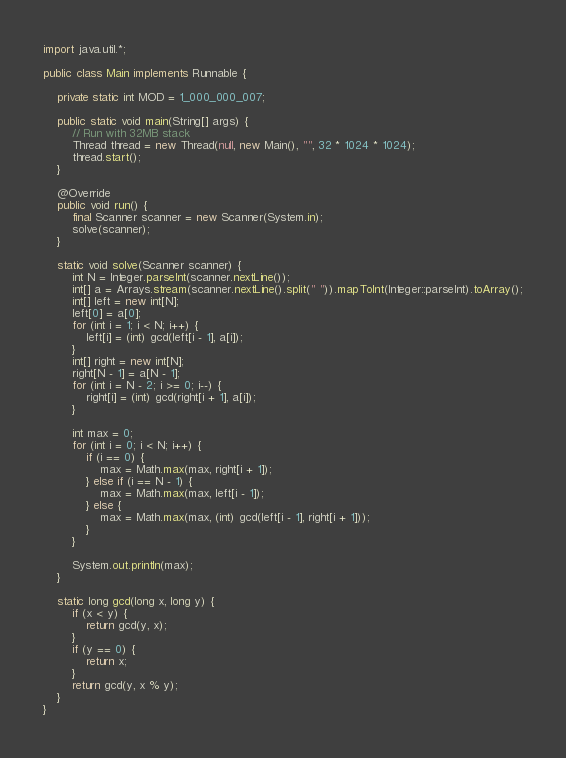<code> <loc_0><loc_0><loc_500><loc_500><_Java_>import java.util.*;

public class Main implements Runnable {

    private static int MOD = 1_000_000_007;

    public static void main(String[] args) {
        // Run with 32MB stack
        Thread thread = new Thread(null, new Main(), "", 32 * 1024 * 1024);
        thread.start();
    }

    @Override
    public void run() {
        final Scanner scanner = new Scanner(System.in);
        solve(scanner);
    }

    static void solve(Scanner scanner) {
        int N = Integer.parseInt(scanner.nextLine());
        int[] a = Arrays.stream(scanner.nextLine().split(" ")).mapToInt(Integer::parseInt).toArray();
        int[] left = new int[N];
        left[0] = a[0];
        for (int i = 1; i < N; i++) {
            left[i] = (int) gcd(left[i - 1], a[i]);
        }
        int[] right = new int[N];
        right[N - 1] = a[N - 1];
        for (int i = N - 2; i >= 0; i--) {
            right[i] = (int) gcd(right[i + 1], a[i]);
        }

        int max = 0;
        for (int i = 0; i < N; i++) {
            if (i == 0) {
                max = Math.max(max, right[i + 1]);
            } else if (i == N - 1) {
                max = Math.max(max, left[i - 1]);
            } else {
                max = Math.max(max, (int) gcd(left[i - 1], right[i + 1]));
            }
        }

        System.out.println(max);
    }

    static long gcd(long x, long y) {
        if (x < y) {
            return gcd(y, x);
        }
        if (y == 0) {
            return x;
        }
        return gcd(y, x % y);
    }
}</code> 